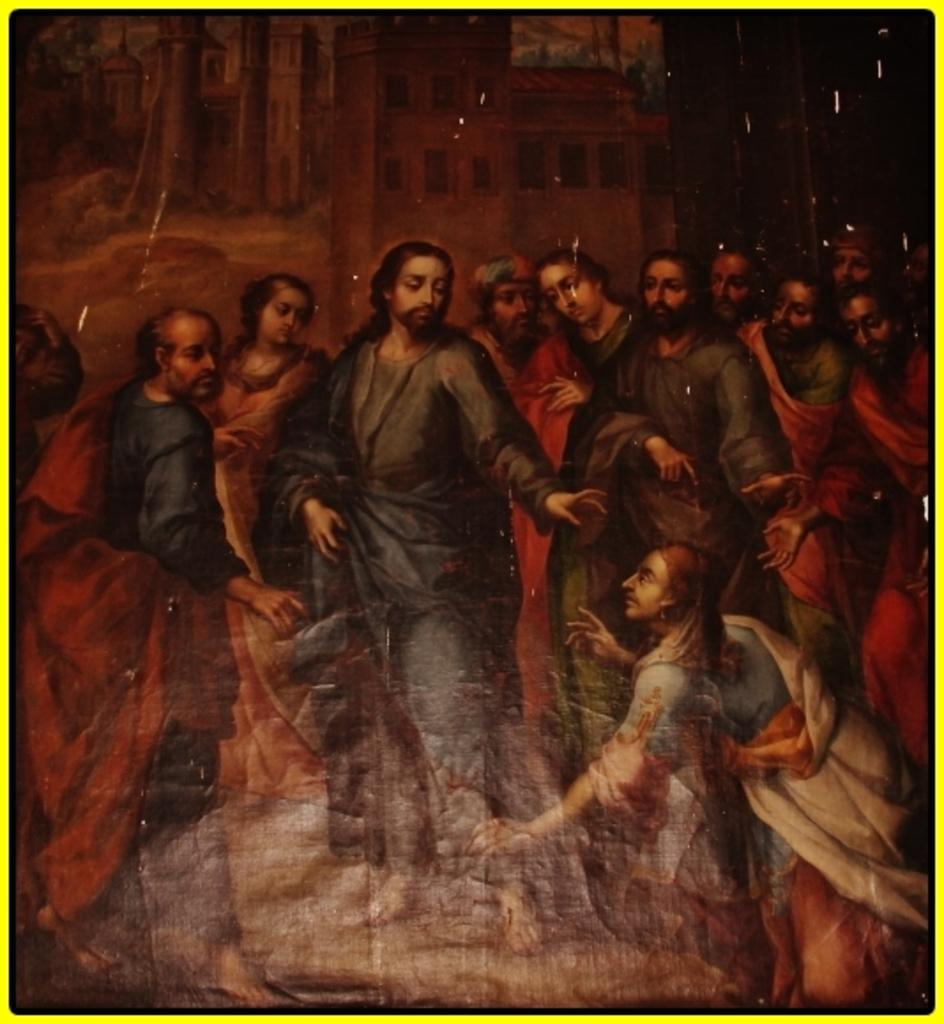How many people are in the image? There are many people in the image. What are the people in the image doing? The people are standing. What type of cakes are being served to the people in the image? There is no mention of cakes or any food being served in the image. What material is the leather used for in the image? There is no mention of leather or any material in the image. 